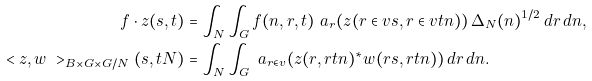Convert formula to latex. <formula><loc_0><loc_0><loc_500><loc_500>f \cdot z ( s , t ) & = \int _ { N } \int _ { G } f ( n , r , t ) \ a _ { r } ( z ( r \in v s , r \in v t n ) ) \, \Delta _ { N } ( n ) ^ { 1 / 2 } \, d r \, d n , \\ \ < { z } , { w } \ > _ { B \times G \times G / N } ( s , t N ) & = \int _ { N } \int _ { G } \ a _ { r \in v } ( z ( r , r t n ) ^ { * } w ( r s , r t n ) ) \, d r \, d n .</formula> 